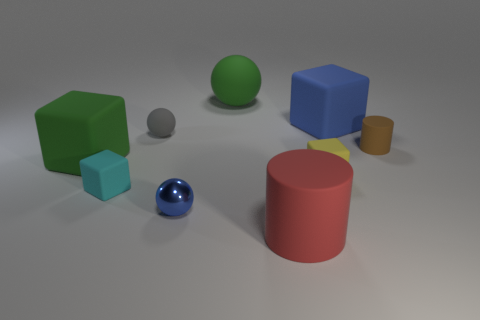What shape is the brown matte object?
Your response must be concise. Cylinder. There is a object in front of the tiny sphere that is in front of the cylinder that is to the right of the yellow rubber cube; what is its material?
Provide a short and direct response. Rubber. How many other objects are the same material as the tiny yellow block?
Give a very brief answer. 7. How many small matte cylinders are to the left of the green matte object that is behind the green rubber block?
Provide a succinct answer. 0. How many cylinders are either big things or tiny brown objects?
Provide a succinct answer. 2. There is a matte thing that is both in front of the yellow thing and behind the big red matte cylinder; what color is it?
Keep it short and to the point. Cyan. Is there any other thing of the same color as the small cylinder?
Your response must be concise. No. What is the color of the big cube in front of the rubber cylinder that is behind the small cyan matte block?
Provide a short and direct response. Green. Is the size of the brown cylinder the same as the gray thing?
Offer a very short reply. Yes. Does the blue thing on the left side of the large red matte cylinder have the same material as the large cube that is on the right side of the tiny matte sphere?
Ensure brevity in your answer.  No. 